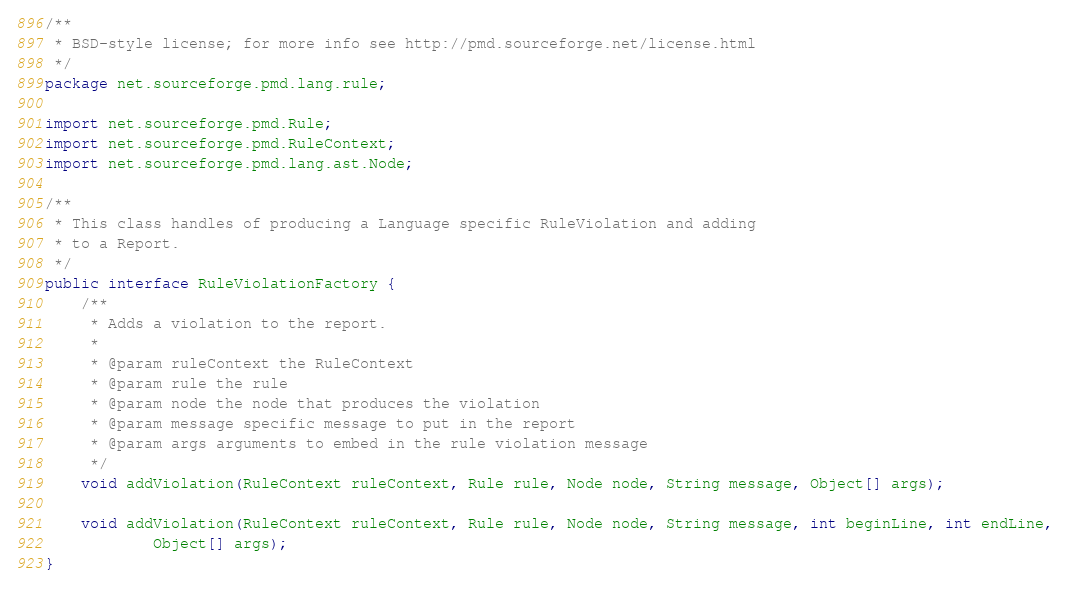Convert code to text. <code><loc_0><loc_0><loc_500><loc_500><_Java_>/**
 * BSD-style license; for more info see http://pmd.sourceforge.net/license.html
 */
package net.sourceforge.pmd.lang.rule;

import net.sourceforge.pmd.Rule;
import net.sourceforge.pmd.RuleContext;
import net.sourceforge.pmd.lang.ast.Node;

/**
 * This class handles of producing a Language specific RuleViolation and adding
 * to a Report.
 */
public interface RuleViolationFactory {
    /**
     * Adds a violation to the report.
     * 
     * @param ruleContext the RuleContext
     * @param rule the rule
     * @param node the node that produces the violation
     * @param message specific message to put in the report
     * @param args arguments to embed in the rule violation message
     */
    void addViolation(RuleContext ruleContext, Rule rule, Node node, String message, Object[] args);

    void addViolation(RuleContext ruleContext, Rule rule, Node node, String message, int beginLine, int endLine,
            Object[] args);
}
</code> 